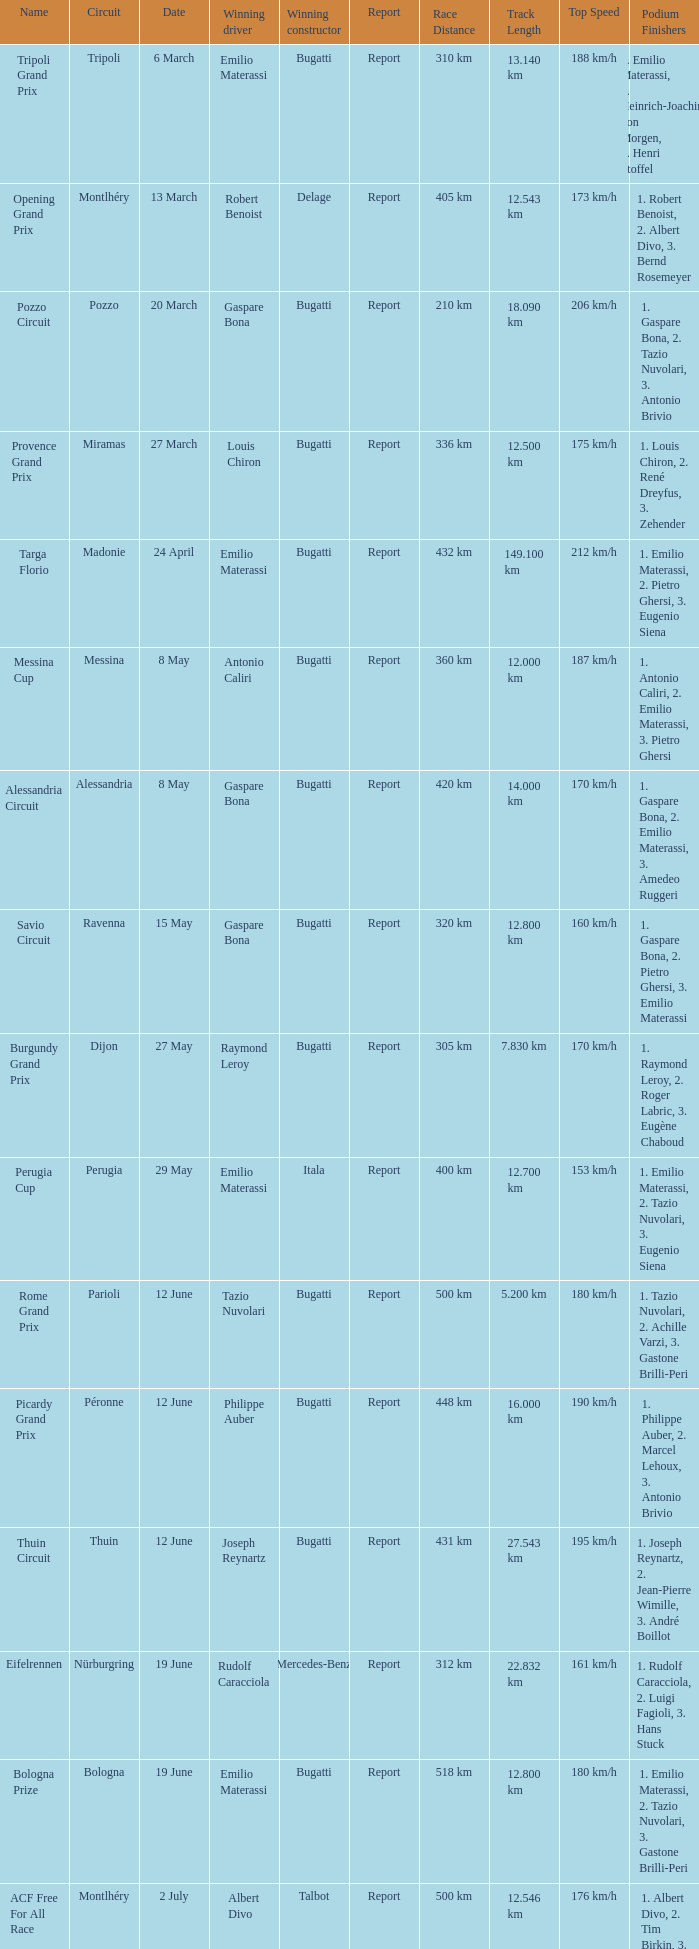When did Gaspare Bona win the Pozzo Circuit? 20 March. 